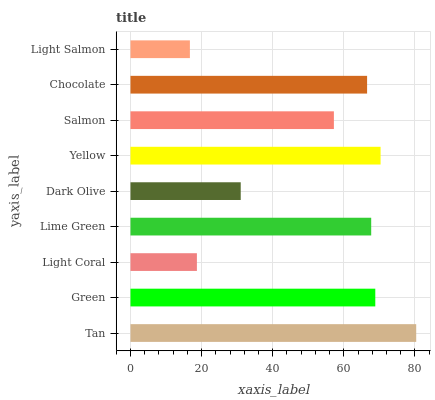Is Light Salmon the minimum?
Answer yes or no. Yes. Is Tan the maximum?
Answer yes or no. Yes. Is Green the minimum?
Answer yes or no. No. Is Green the maximum?
Answer yes or no. No. Is Tan greater than Green?
Answer yes or no. Yes. Is Green less than Tan?
Answer yes or no. Yes. Is Green greater than Tan?
Answer yes or no. No. Is Tan less than Green?
Answer yes or no. No. Is Chocolate the high median?
Answer yes or no. Yes. Is Chocolate the low median?
Answer yes or no. Yes. Is Salmon the high median?
Answer yes or no. No. Is Yellow the low median?
Answer yes or no. No. 